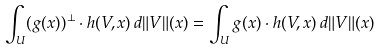<formula> <loc_0><loc_0><loc_500><loc_500>\int _ { U } ( g ( x ) ) ^ { \perp } \cdot h ( V , x ) \, d \| V \| ( x ) = \int _ { U } g ( x ) \cdot h ( V , x ) \, d \| V \| ( x )</formula> 